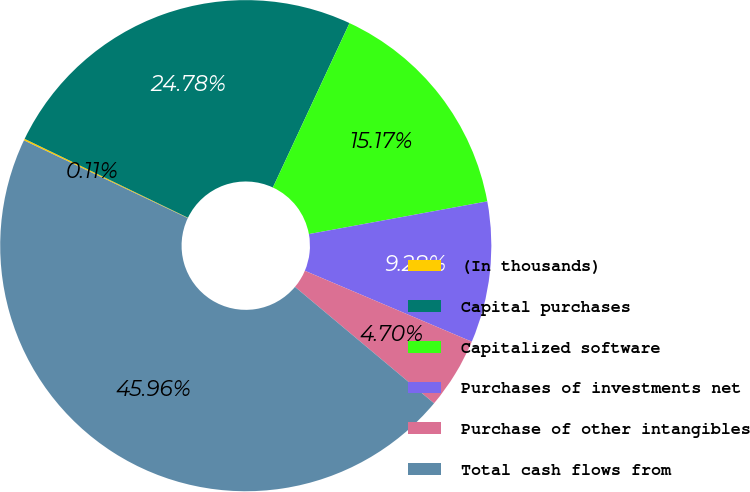Convert chart to OTSL. <chart><loc_0><loc_0><loc_500><loc_500><pie_chart><fcel>(In thousands)<fcel>Capital purchases<fcel>Capitalized software<fcel>Purchases of investments net<fcel>Purchase of other intangibles<fcel>Total cash flows from<nl><fcel>0.11%<fcel>24.78%<fcel>15.17%<fcel>9.28%<fcel>4.7%<fcel>45.96%<nl></chart> 